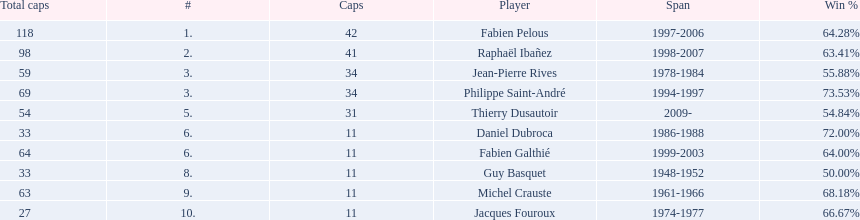How long did michel crauste serve as captain? 1961-1966. 